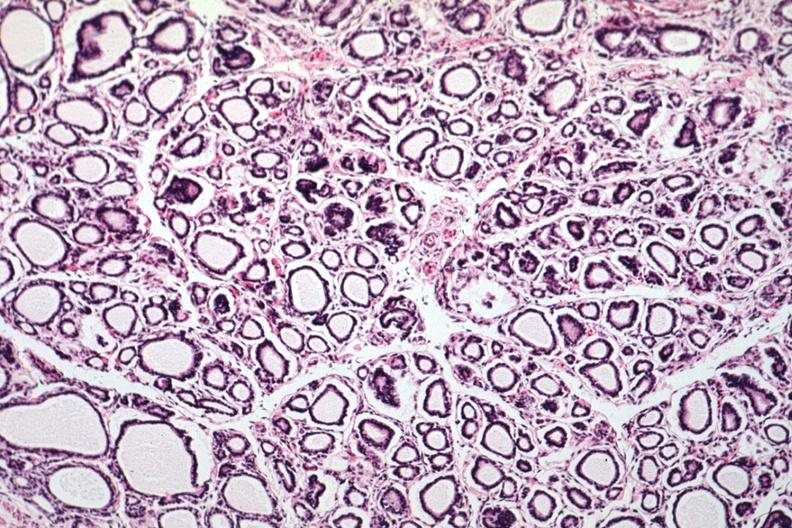s newborn cord around neck present?
Answer the question using a single word or phrase. No 